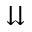<formula> <loc_0><loc_0><loc_500><loc_500>\downdownarrows</formula> 